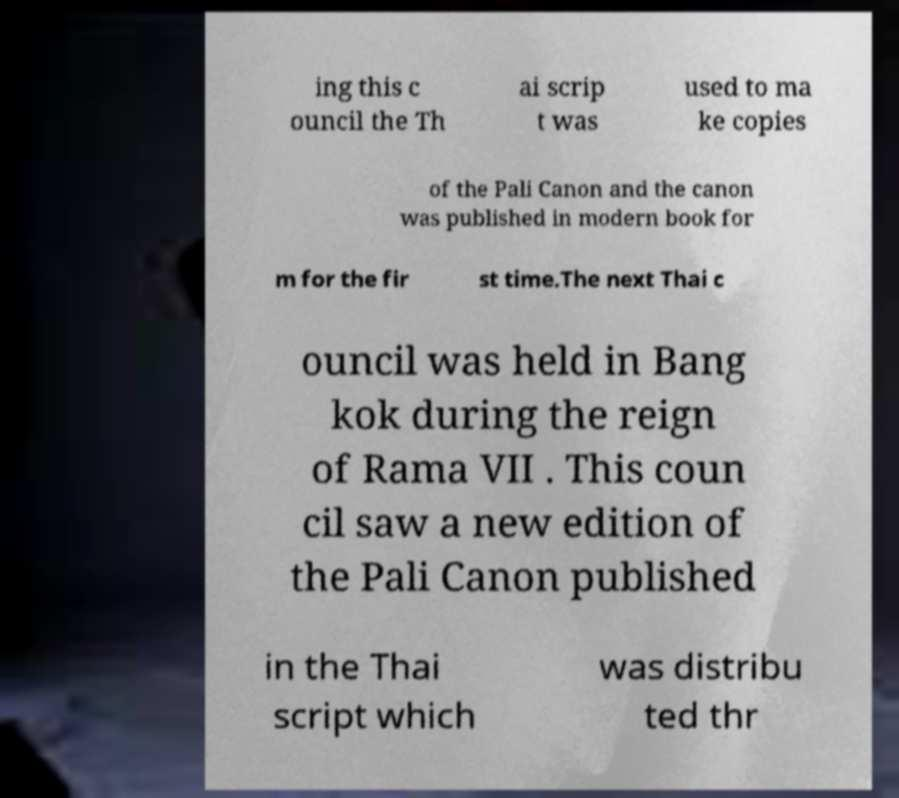Please read and relay the text visible in this image. What does it say? ing this c ouncil the Th ai scrip t was used to ma ke copies of the Pali Canon and the canon was published in modern book for m for the fir st time.The next Thai c ouncil was held in Bang kok during the reign of Rama VII . This coun cil saw a new edition of the Pali Canon published in the Thai script which was distribu ted thr 